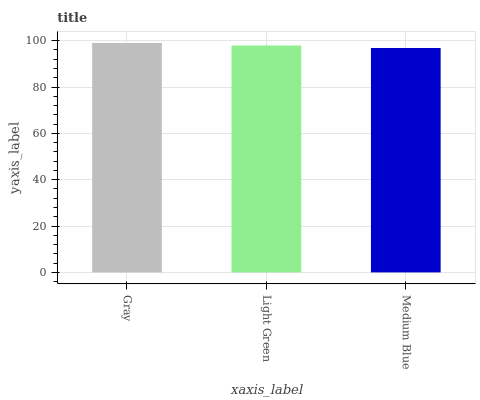Is Medium Blue the minimum?
Answer yes or no. Yes. Is Gray the maximum?
Answer yes or no. Yes. Is Light Green the minimum?
Answer yes or no. No. Is Light Green the maximum?
Answer yes or no. No. Is Gray greater than Light Green?
Answer yes or no. Yes. Is Light Green less than Gray?
Answer yes or no. Yes. Is Light Green greater than Gray?
Answer yes or no. No. Is Gray less than Light Green?
Answer yes or no. No. Is Light Green the high median?
Answer yes or no. Yes. Is Light Green the low median?
Answer yes or no. Yes. Is Gray the high median?
Answer yes or no. No. Is Medium Blue the low median?
Answer yes or no. No. 